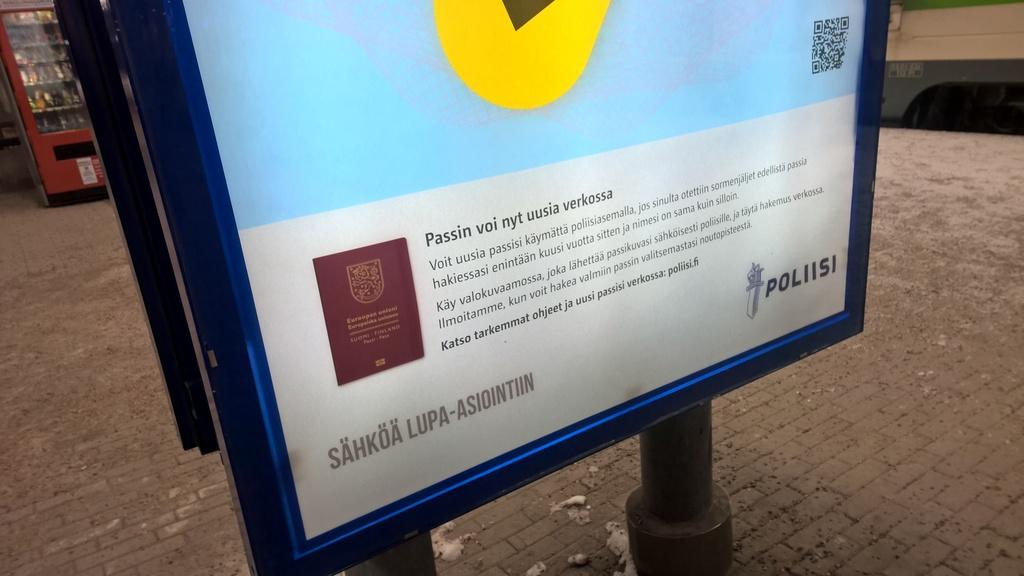Provide a one-sentence caption for the provided image. A lit sign includes the name Poliisi in the bottom corner. 